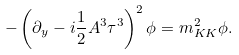Convert formula to latex. <formula><loc_0><loc_0><loc_500><loc_500>- \left ( \partial _ { y } - i \frac { 1 } { 2 } A ^ { 3 } \tau ^ { 3 } \right ) ^ { 2 } \phi = m _ { K K } ^ { 2 } \phi .</formula> 